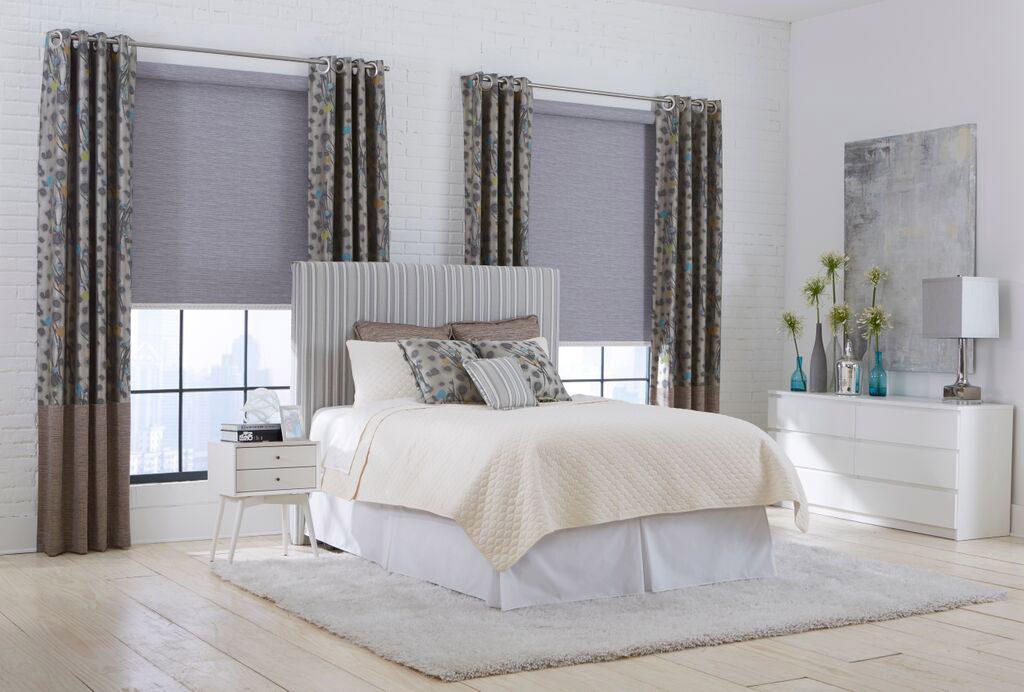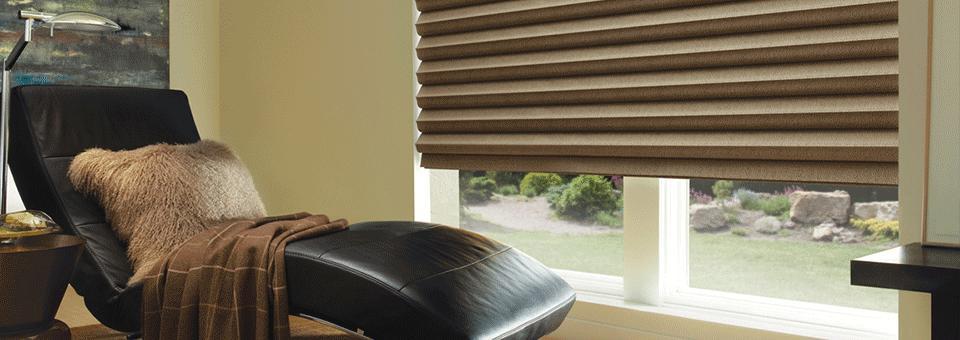The first image is the image on the left, the second image is the image on the right. Given the left and right images, does the statement "One image shows the headboard of a bed in front of two windows with solid-colored shades, and a table lamp is nearby on a dresser." hold true? Answer yes or no. Yes. The first image is the image on the left, the second image is the image on the right. For the images displayed, is the sentence "There is a total of four blinds." factually correct? Answer yes or no. No. 